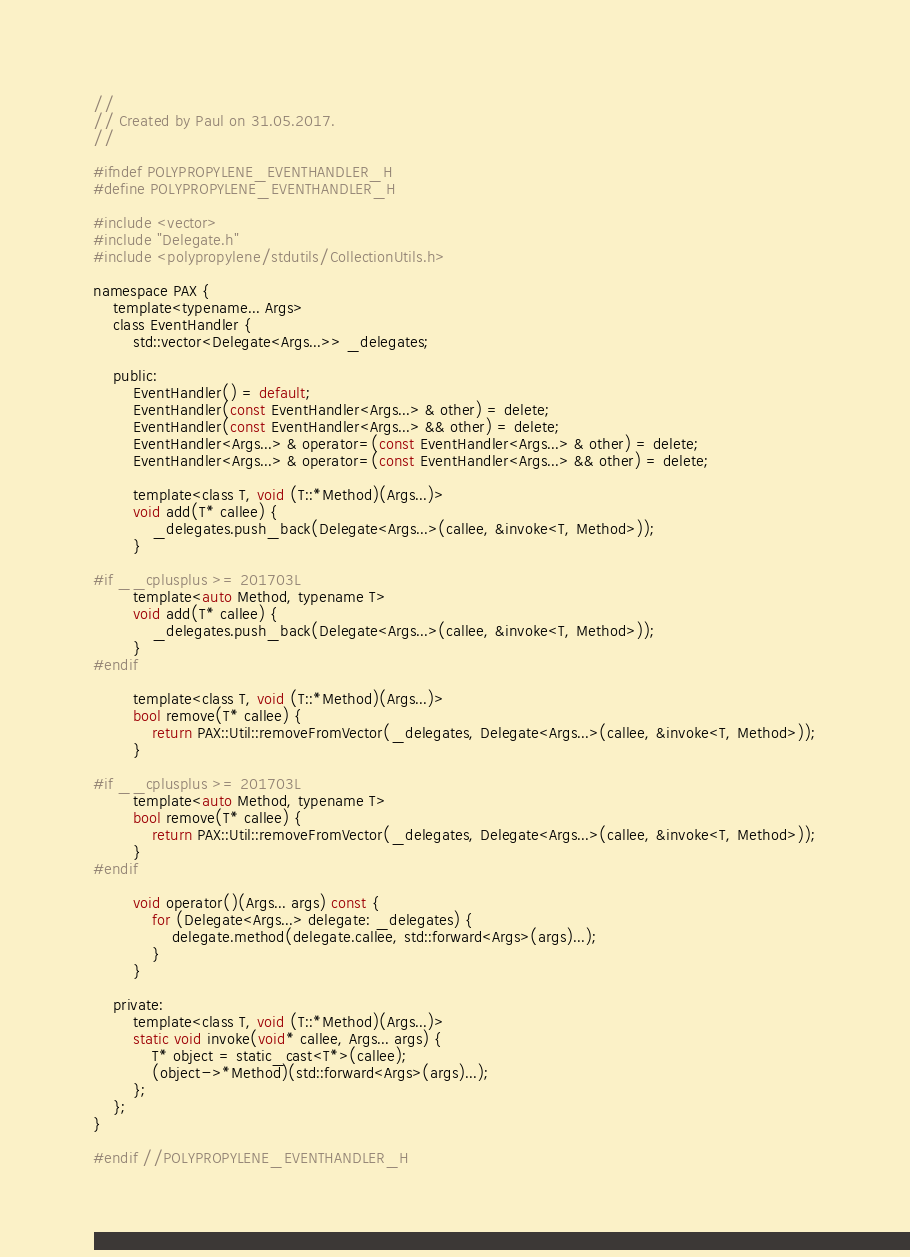Convert code to text. <code><loc_0><loc_0><loc_500><loc_500><_C_>//
// Created by Paul on 31.05.2017.
//

#ifndef POLYPROPYLENE_EVENTHANDLER_H
#define POLYPROPYLENE_EVENTHANDLER_H

#include <vector>
#include "Delegate.h"
#include <polypropylene/stdutils/CollectionUtils.h>

namespace PAX {
    template<typename... Args>
    class EventHandler {
        std::vector<Delegate<Args...>> _delegates;

    public:
        EventHandler() = default;
        EventHandler(const EventHandler<Args...> & other) = delete;
        EventHandler(const EventHandler<Args...> && other) = delete;
        EventHandler<Args...> & operator=(const EventHandler<Args...> & other) = delete;
        EventHandler<Args...> & operator=(const EventHandler<Args...> && other) = delete;

        template<class T, void (T::*Method)(Args...)>
        void add(T* callee) {
            _delegates.push_back(Delegate<Args...>(callee, &invoke<T, Method>));
        }

#if __cplusplus >= 201703L
        template<auto Method, typename T>
        void add(T* callee) {
            _delegates.push_back(Delegate<Args...>(callee, &invoke<T, Method>));
        }
#endif

        template<class T, void (T::*Method)(Args...)>
        bool remove(T* callee) {
            return PAX::Util::removeFromVector(_delegates, Delegate<Args...>(callee, &invoke<T, Method>));
        }

#if __cplusplus >= 201703L
        template<auto Method, typename T>
        bool remove(T* callee) {
            return PAX::Util::removeFromVector(_delegates, Delegate<Args...>(callee, &invoke<T, Method>));
        }
#endif

        void operator()(Args... args) const {
            for (Delegate<Args...> delegate: _delegates) {
                delegate.method(delegate.callee, std::forward<Args>(args)...);
            }
        }

    private:
        template<class T, void (T::*Method)(Args...)>
        static void invoke(void* callee, Args... args) {
            T* object = static_cast<T*>(callee);
            (object->*Method)(std::forward<Args>(args)...);
        };
    };
}

#endif //POLYPROPYLENE_EVENTHANDLER_H
</code> 